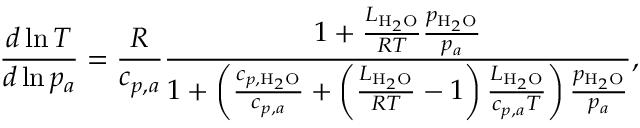Convert formula to latex. <formula><loc_0><loc_0><loc_500><loc_500>\frac { d \ln { T } } { d \ln { p _ { a } } } = \frac { R } { c _ { p , a } } \frac { 1 + \frac { L _ { H _ { 2 } O } } { R T } \frac { p _ { H _ { 2 } O } } { p _ { a } } } { 1 + \left ( \frac { c _ { p , H _ { 2 } O } } { c _ { p , a } } + \left ( \frac { L _ { H _ { 2 } O } } { R T } - 1 \right ) \frac { L _ { H _ { 2 } O } } { c _ { p , a } T } \right ) \frac { p _ { H _ { 2 } O } } { p _ { a } } } ,</formula> 